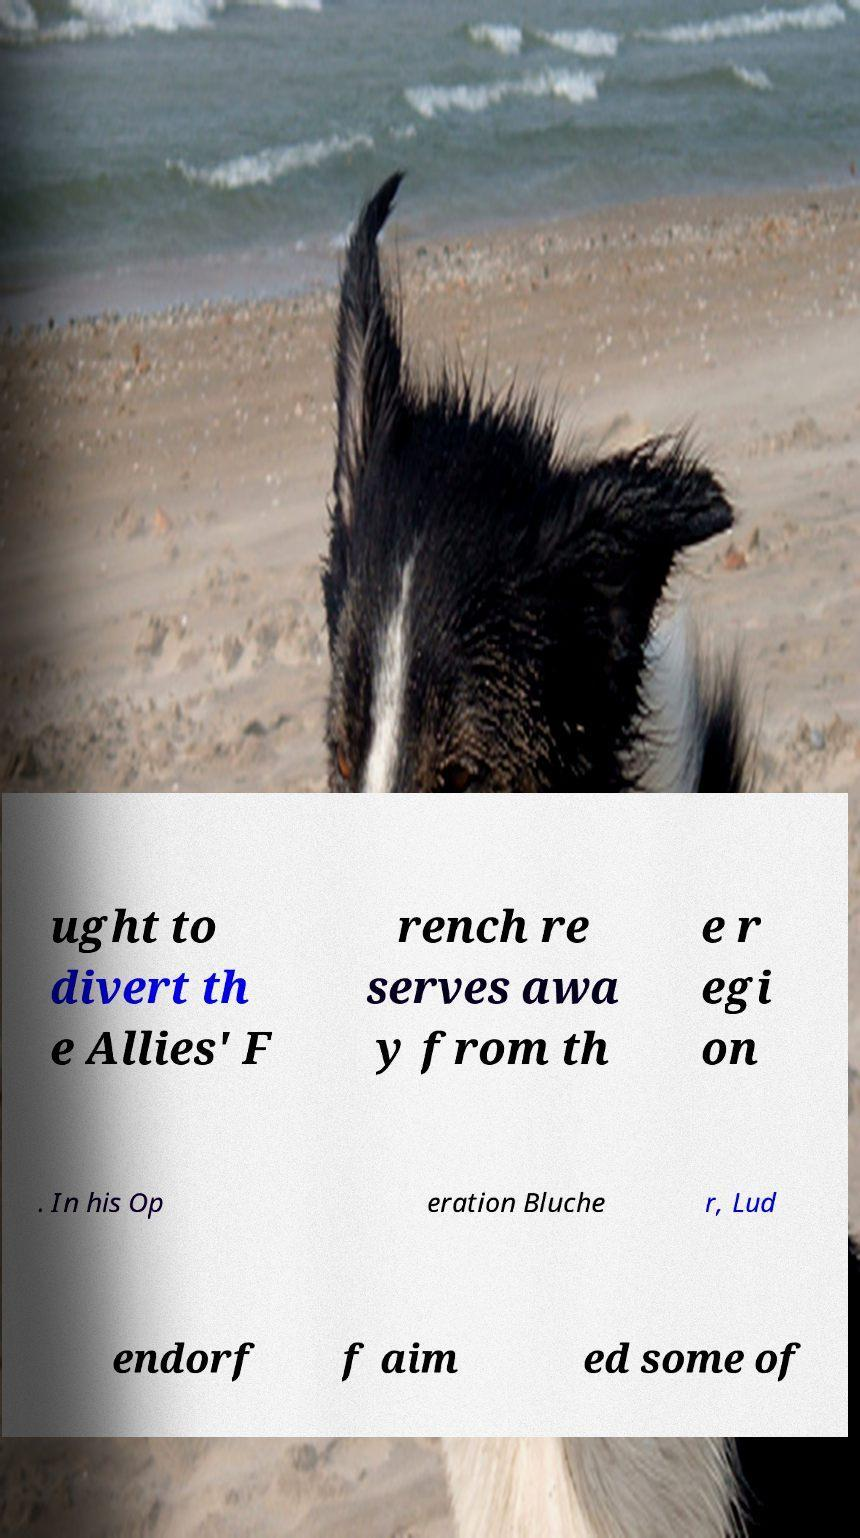Please identify and transcribe the text found in this image. ught to divert th e Allies' F rench re serves awa y from th e r egi on . In his Op eration Bluche r, Lud endorf f aim ed some of 